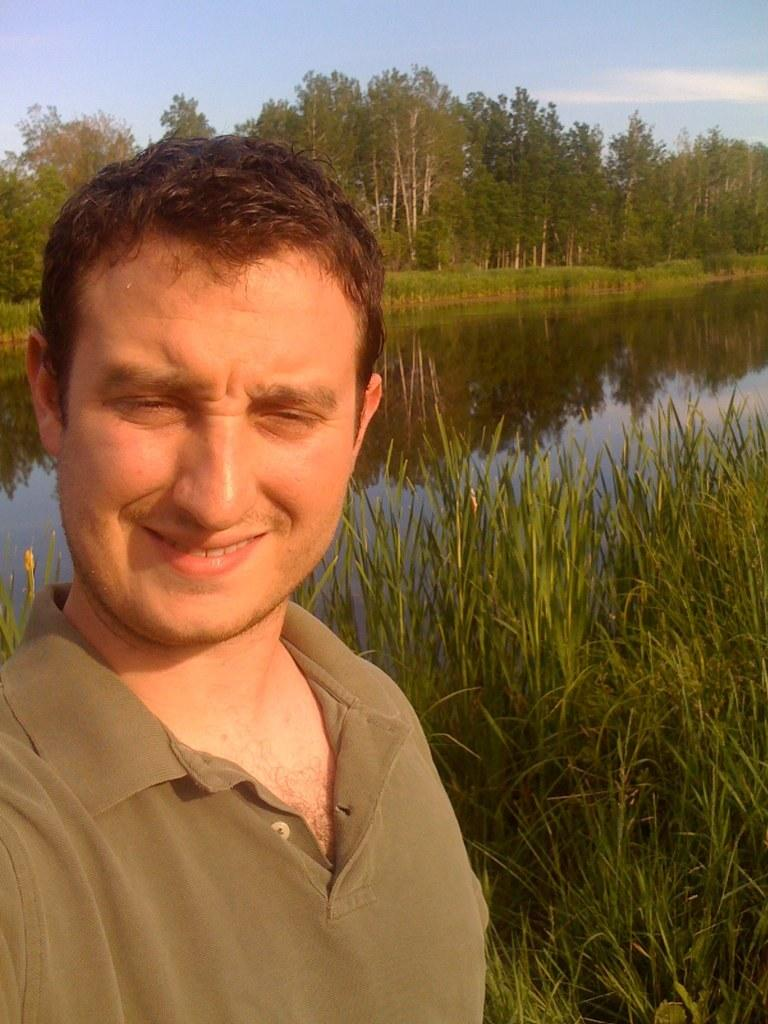What is the main subject of the image? There is a man in the image. What is the man doing in the image? The man is standing in the image. What is the man's facial expression in the image? The man is smiling in the image. What type of natural environment is visible in the image? There is grass, water, trees, clouds, and the sky visible in the image. What type of pain is the man experiencing in the image? There is no indication in the image that the man is experiencing any pain. How many toes can be seen on the man's feet in the image? The man's feet are not visible in the image, so it is impossible to determine the number of toes. 